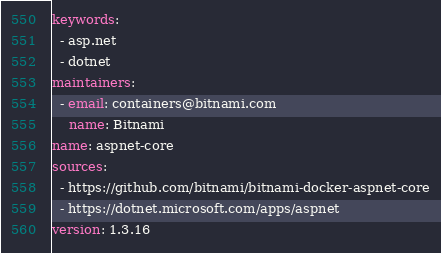Convert code to text. <code><loc_0><loc_0><loc_500><loc_500><_YAML_>keywords:
  - asp.net
  - dotnet
maintainers:
  - email: containers@bitnami.com
    name: Bitnami
name: aspnet-core
sources:
  - https://github.com/bitnami/bitnami-docker-aspnet-core
  - https://dotnet.microsoft.com/apps/aspnet
version: 1.3.16
</code> 